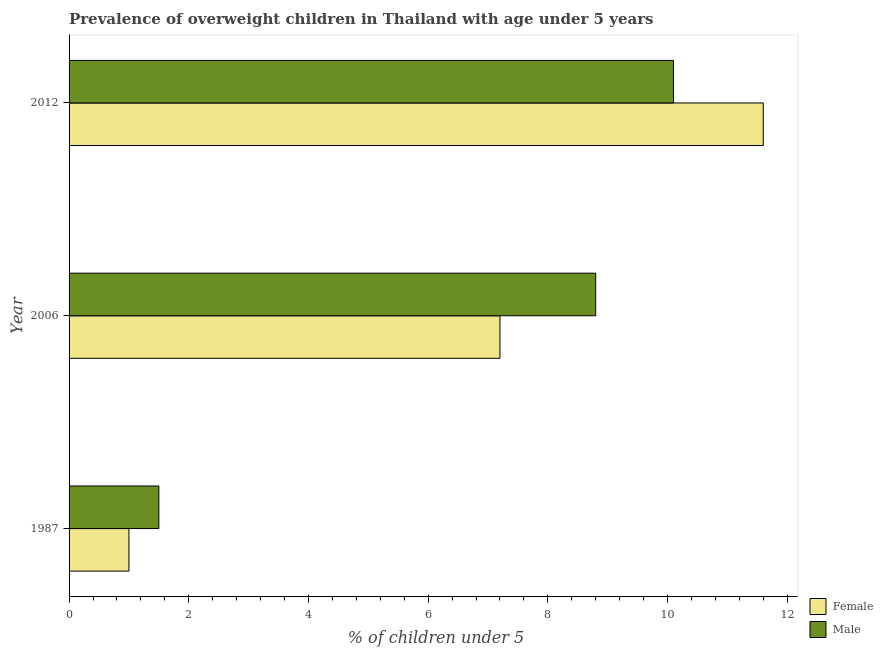Are the number of bars on each tick of the Y-axis equal?
Offer a very short reply. Yes. How many bars are there on the 3rd tick from the top?
Give a very brief answer. 2. How many bars are there on the 3rd tick from the bottom?
Offer a terse response. 2. What is the label of the 1st group of bars from the top?
Make the answer very short. 2012. Across all years, what is the maximum percentage of obese male children?
Your answer should be very brief. 10.1. In which year was the percentage of obese female children maximum?
Offer a terse response. 2012. In which year was the percentage of obese male children minimum?
Your answer should be compact. 1987. What is the total percentage of obese male children in the graph?
Give a very brief answer. 20.4. What is the difference between the percentage of obese male children in 2006 and the percentage of obese female children in 1987?
Offer a terse response. 7.8. In the year 2006, what is the difference between the percentage of obese male children and percentage of obese female children?
Your response must be concise. 1.6. What is the ratio of the percentage of obese male children in 1987 to that in 2006?
Keep it short and to the point. 0.17. What is the difference between the highest and the lowest percentage of obese female children?
Offer a very short reply. 10.6. Is the sum of the percentage of obese male children in 1987 and 2006 greater than the maximum percentage of obese female children across all years?
Your response must be concise. No. Where does the legend appear in the graph?
Your answer should be very brief. Bottom right. How many legend labels are there?
Ensure brevity in your answer.  2. What is the title of the graph?
Your answer should be compact. Prevalence of overweight children in Thailand with age under 5 years. What is the label or title of the X-axis?
Your response must be concise.  % of children under 5. What is the  % of children under 5 of Male in 1987?
Offer a terse response. 1.5. What is the  % of children under 5 in Female in 2006?
Provide a short and direct response. 7.2. What is the  % of children under 5 in Male in 2006?
Make the answer very short. 8.8. What is the  % of children under 5 of Female in 2012?
Provide a succinct answer. 11.6. What is the  % of children under 5 in Male in 2012?
Provide a short and direct response. 10.1. Across all years, what is the maximum  % of children under 5 in Female?
Give a very brief answer. 11.6. Across all years, what is the maximum  % of children under 5 in Male?
Keep it short and to the point. 10.1. What is the total  % of children under 5 in Female in the graph?
Make the answer very short. 19.8. What is the total  % of children under 5 in Male in the graph?
Keep it short and to the point. 20.4. What is the difference between the  % of children under 5 in Female in 1987 and that in 2006?
Give a very brief answer. -6.2. What is the difference between the  % of children under 5 of Female in 1987 and the  % of children under 5 of Male in 2006?
Your answer should be very brief. -7.8. What is the difference between the  % of children under 5 in Female in 1987 and the  % of children under 5 in Male in 2012?
Your response must be concise. -9.1. What is the average  % of children under 5 in Male per year?
Ensure brevity in your answer.  6.8. In the year 2006, what is the difference between the  % of children under 5 in Female and  % of children under 5 in Male?
Provide a succinct answer. -1.6. In the year 2012, what is the difference between the  % of children under 5 in Female and  % of children under 5 in Male?
Your response must be concise. 1.5. What is the ratio of the  % of children under 5 of Female in 1987 to that in 2006?
Give a very brief answer. 0.14. What is the ratio of the  % of children under 5 of Male in 1987 to that in 2006?
Provide a short and direct response. 0.17. What is the ratio of the  % of children under 5 in Female in 1987 to that in 2012?
Provide a succinct answer. 0.09. What is the ratio of the  % of children under 5 of Male in 1987 to that in 2012?
Keep it short and to the point. 0.15. What is the ratio of the  % of children under 5 in Female in 2006 to that in 2012?
Offer a very short reply. 0.62. What is the ratio of the  % of children under 5 of Male in 2006 to that in 2012?
Offer a terse response. 0.87. 